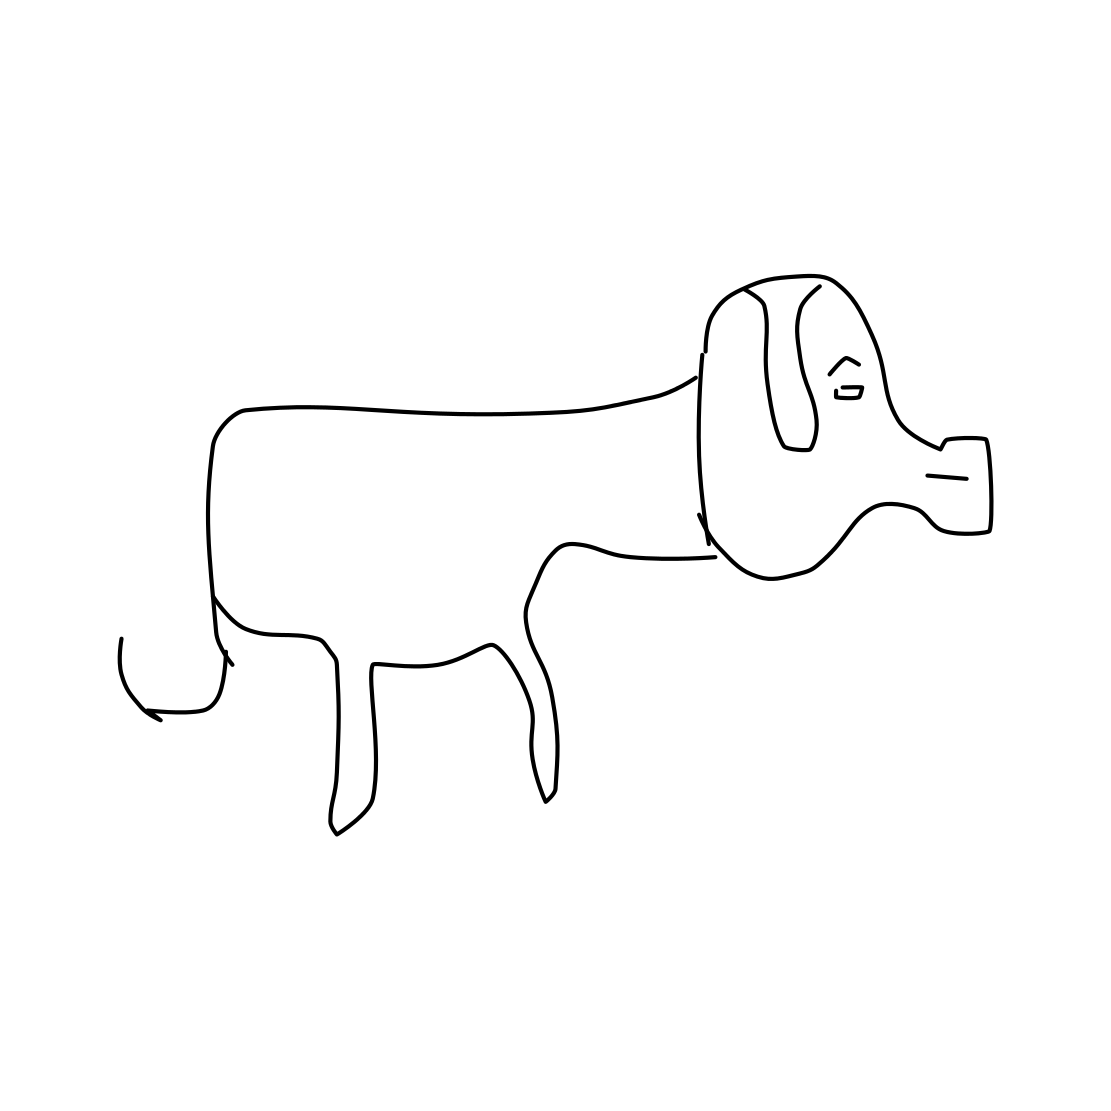Can you tell me what breed of dog this might represent? While the image is quite stylized and lacks detail, it may be intended to represent a generic dog breed rather than a specific one. The simplicity of the drawing makes it challenging to assign a breed with certainty. 